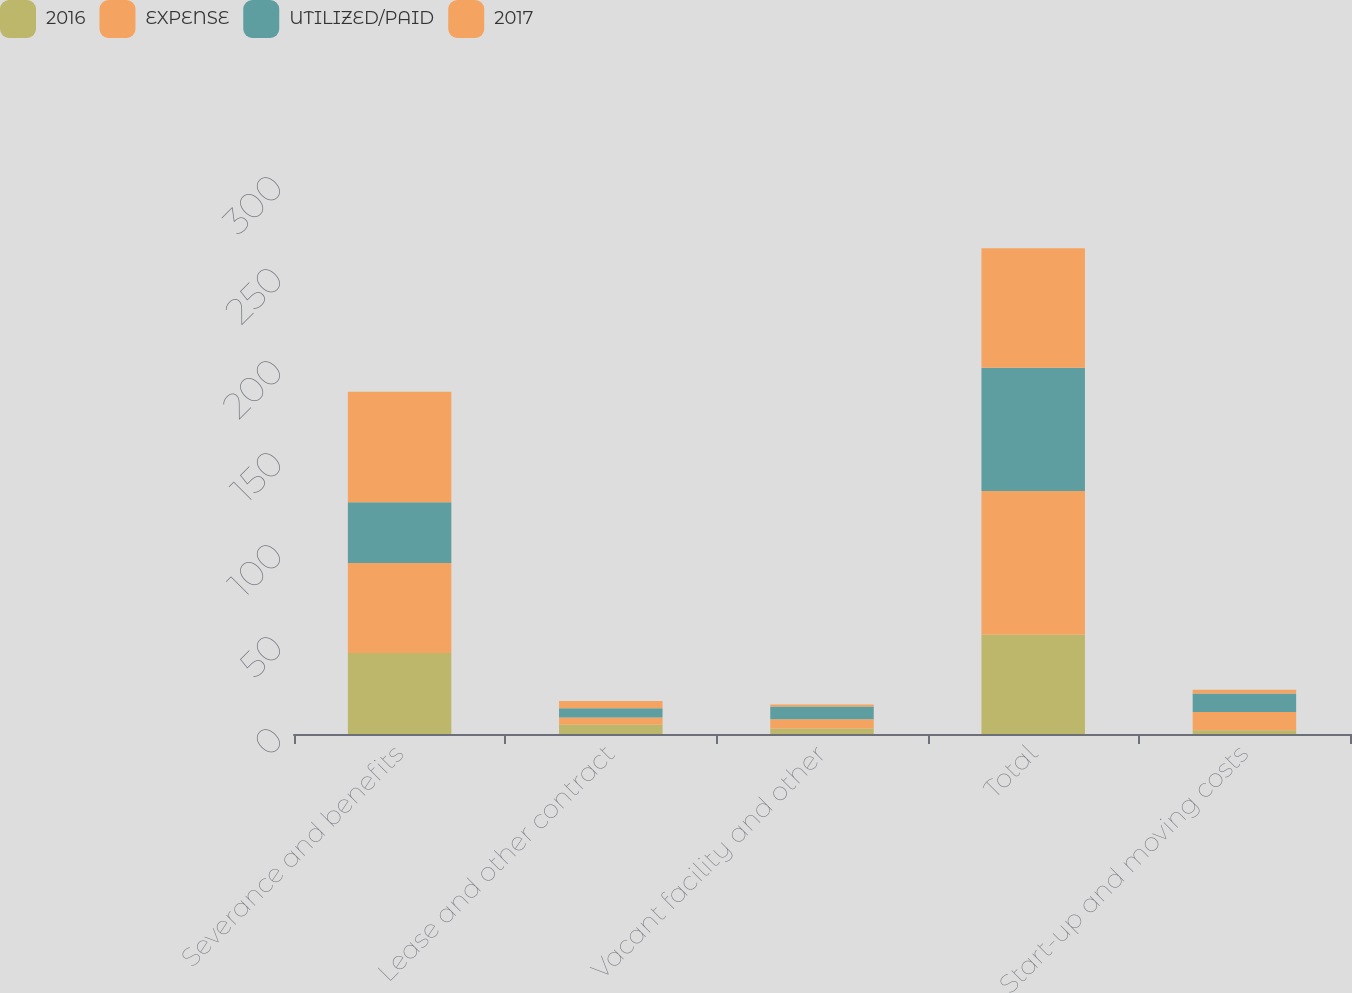Convert chart to OTSL. <chart><loc_0><loc_0><loc_500><loc_500><stacked_bar_chart><ecel><fcel>Severance and benefits<fcel>Lease and other contract<fcel>Vacant facility and other<fcel>Total<fcel>Start-up and moving costs<nl><fcel>2016<fcel>44<fcel>5<fcel>3<fcel>54<fcel>2<nl><fcel>EXPENSE<fcel>49<fcel>4<fcel>5<fcel>78<fcel>10<nl><fcel>UTILIZED/PAID<fcel>33<fcel>5<fcel>7<fcel>67<fcel>10<nl><fcel>2017<fcel>60<fcel>4<fcel>1<fcel>65<fcel>2<nl></chart> 